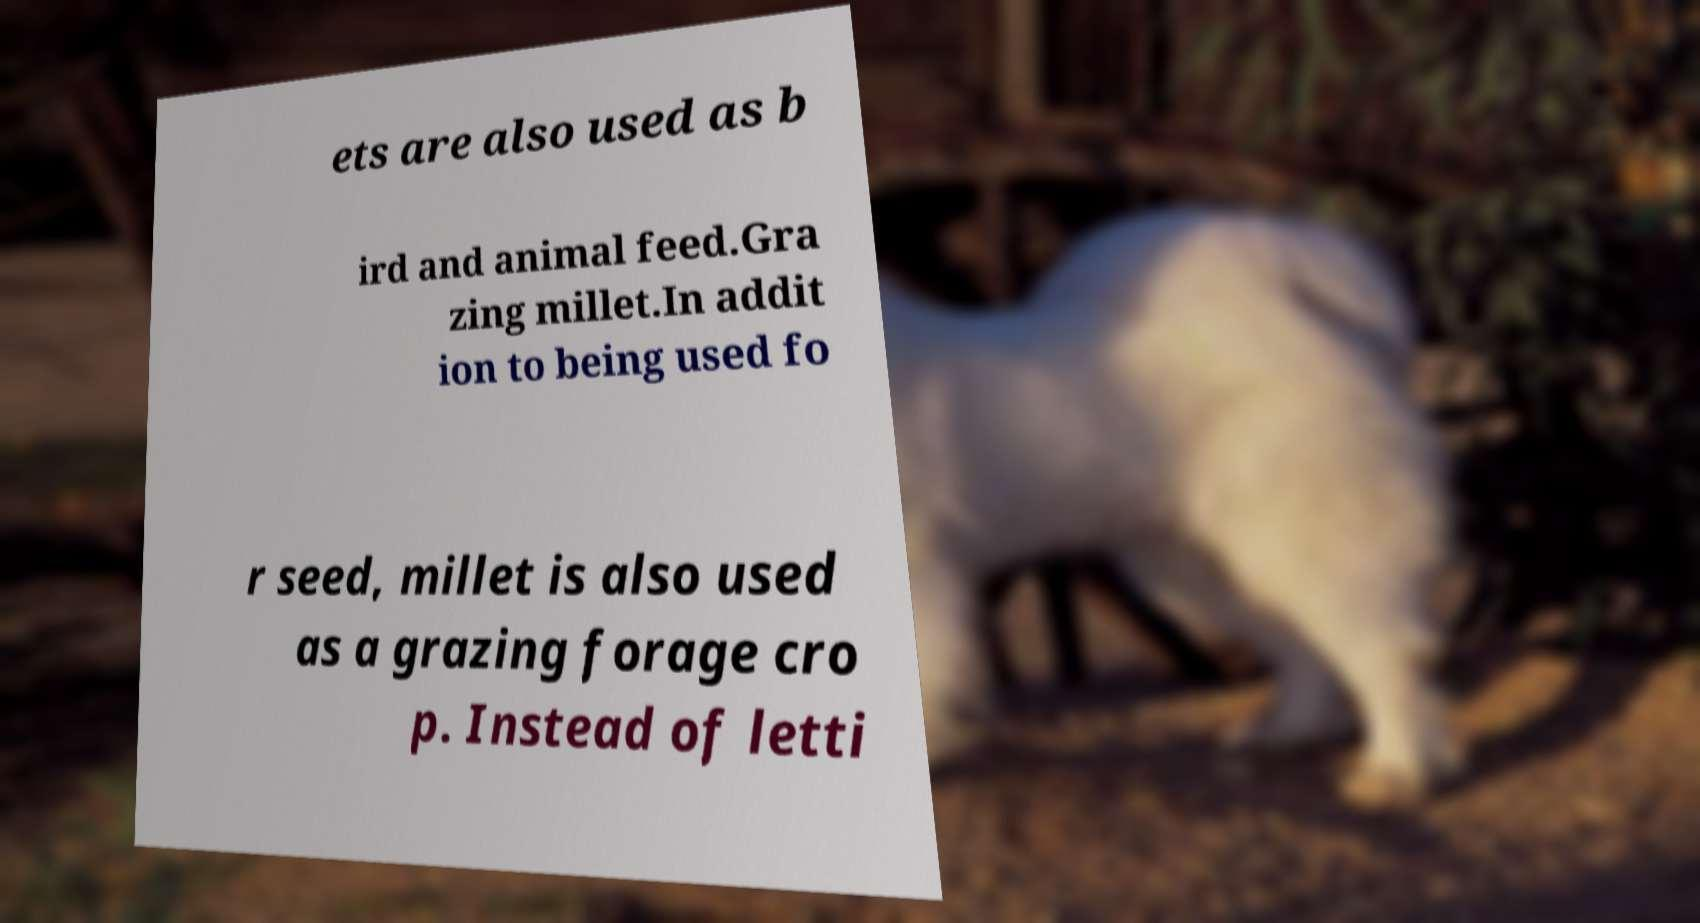Could you assist in decoding the text presented in this image and type it out clearly? ets are also used as b ird and animal feed.Gra zing millet.In addit ion to being used fo r seed, millet is also used as a grazing forage cro p. Instead of letti 